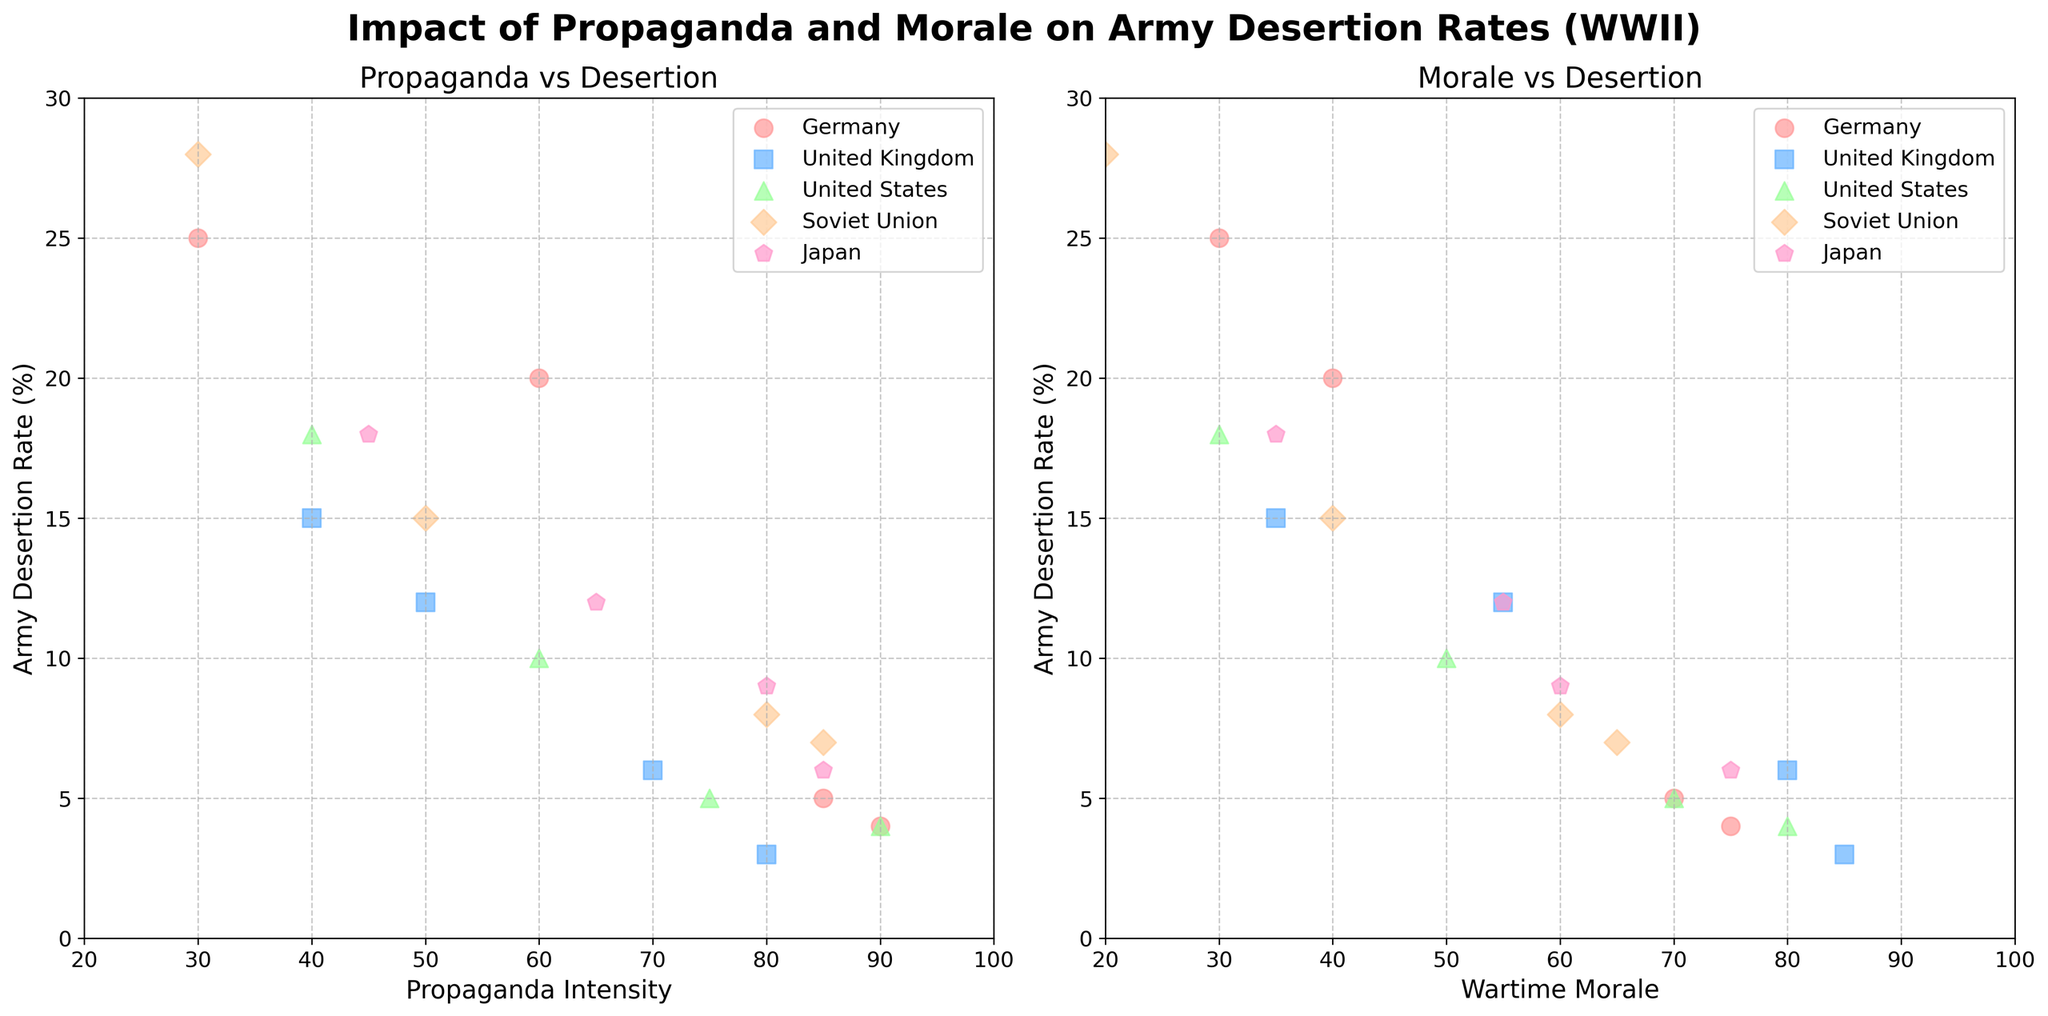How many countries are represented in the figure? There are color-coded markers used in the figure, and each color represents a distinct country. Counting the unique colors, we find five different countries.
Answer: 5 Which country has the highest propaganda intensity with the lowest desertion rate in the 'Propaganda vs Desertion' plot? In the 'Propaganda vs Desertion' plot, we observe that the United States has the highest propaganda intensity (90) and the lowest desertion rate (4).
Answer: United States What is the relationship between wartime morale and army desertion rate for Japan? Observing the 'Morale vs Desertion' plot, we see that as the wartime morale of Japan increases, the army desertion rate decreases. For example, desertion rates go from 18 at a morale of 35, down to 6 at a morale of 75.
Answer: Inverse relationship What is the average desertion rate for the Soviet Union in both plots? Adding up the desertion rates for the Soviet Union (8, 15, 28, 7) and then dividing by the number of data points (4) gives us (8+15+28+7)/4 = 58/4 = 14.5.
Answer: 14.5 Between Germany and the United Kingdom, which country demonstrates a greater spread in propaganda intensity values? Comparing the range of propaganda intensity values for Germany (30 to 90) and the United Kingdom (40 to 80), Germany has a greater spread (60) compared to the United Kingdom (40).
Answer: Germany In the 'Morale vs Desertion' plot, how does the desertion rate change for the United Kingdom as morale increases from 35 to 85? For the United Kingdom, as the wartime morale increases from 35 to 85, the desertion rate decreases from 15 to 3. This indicates a significant drop in desertion rate with increasing morale.
Answer: Decreases What is the difference in the highest morale values between the United States and Japan? The highest wartime morale value for the United States is 80, and for Japan, it is 75. The difference is 80 - 75 = 5.
Answer: 5 Do any countries show a positive correlation between propaganda intensity and desertion rate? If so, which ones? By observing the 'Propaganda vs Desertion' plot, no country clearly demonstrates a positive correlation between propaganda intensity and desertion rate. Most show a negative correlation where higher propaganda intensity is associated with lower desertion rates.
Answer: None What is the maximum desertion rate observed in the dataset? In both plots, the maximum desertion rate observed is for the Soviet Union, which is 28.
Answer: 28 